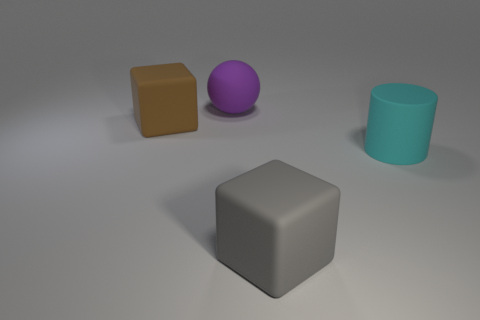What number of rubber objects are either balls or gray blocks?
Offer a terse response. 2. How big is the rubber sphere?
Make the answer very short. Large. There is a cube that is behind the matte cylinder; is there a large purple ball that is to the right of it?
Offer a very short reply. Yes. Do the purple object and the gray matte object have the same shape?
Your answer should be compact. No. There is a large cyan thing that is made of the same material as the big gray thing; what shape is it?
Provide a succinct answer. Cylinder. Are there more big rubber objects that are behind the large gray block than brown cubes that are left of the big brown rubber block?
Your response must be concise. Yes. What number of gray rubber cubes are to the right of the big thing behind the brown matte cube?
Ensure brevity in your answer.  1. There is a thing that is both in front of the brown block and to the left of the big matte cylinder; what material is it?
Your answer should be very brief. Rubber. How many big cyan objects have the same shape as the large brown thing?
Offer a very short reply. 0. There is a big block that is right of the large rubber block on the left side of the purple ball; what number of rubber things are behind it?
Provide a short and direct response. 3. 